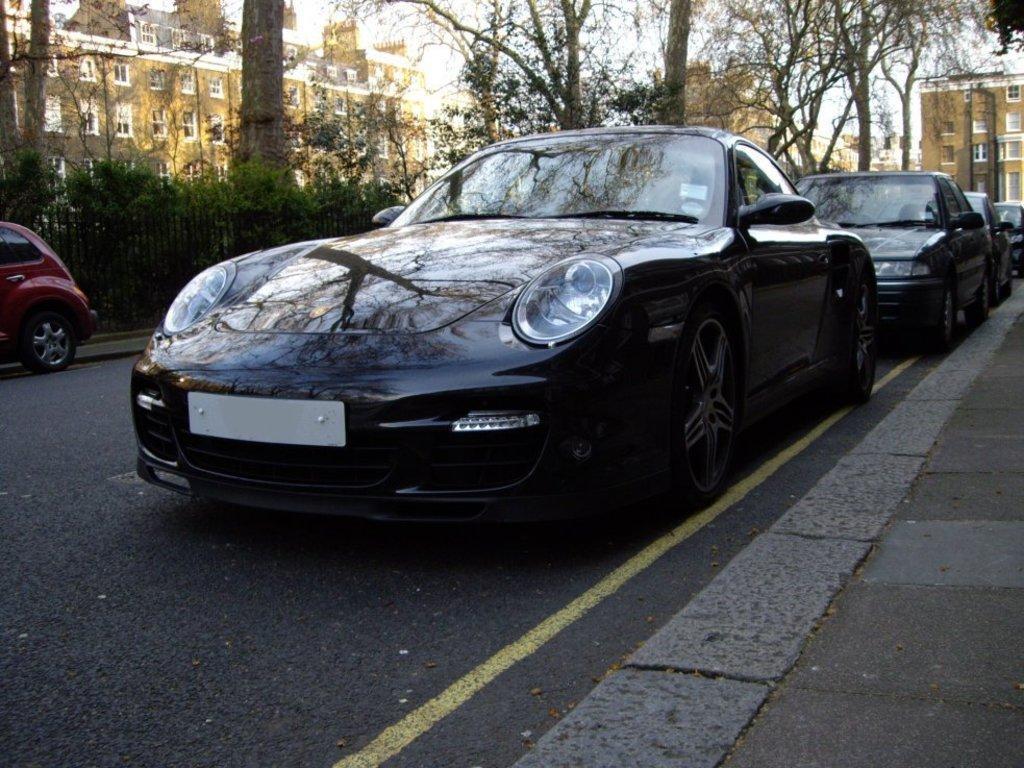Please provide a concise description of this image. In this image we can see a few vehicles on the road and there is a fence. We can see some plants and trees and there are some buildings in the background and at the top we can see the sky. 